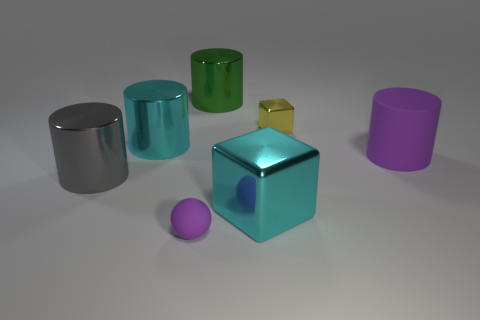Is there anything else that has the same size as the yellow object?
Make the answer very short. Yes. There is a big cyan thing that is the same shape as the big green shiny thing; what is its material?
Your answer should be compact. Metal. There is a small thing in front of the large matte cylinder; is its shape the same as the cyan object behind the gray object?
Give a very brief answer. No. Are there more green metal things than big purple metallic balls?
Keep it short and to the point. Yes. The gray cylinder is what size?
Your response must be concise. Large. How many other objects are there of the same color as the large rubber cylinder?
Ensure brevity in your answer.  1. Does the cyan object in front of the large gray cylinder have the same material as the big cyan cylinder?
Keep it short and to the point. Yes. Are there fewer tiny yellow metallic cubes that are on the right side of the yellow block than rubber cylinders in front of the tiny purple matte sphere?
Provide a short and direct response. No. How many other objects are the same material as the large cyan block?
Give a very brief answer. 4. There is another cyan cylinder that is the same size as the rubber cylinder; what material is it?
Make the answer very short. Metal. 